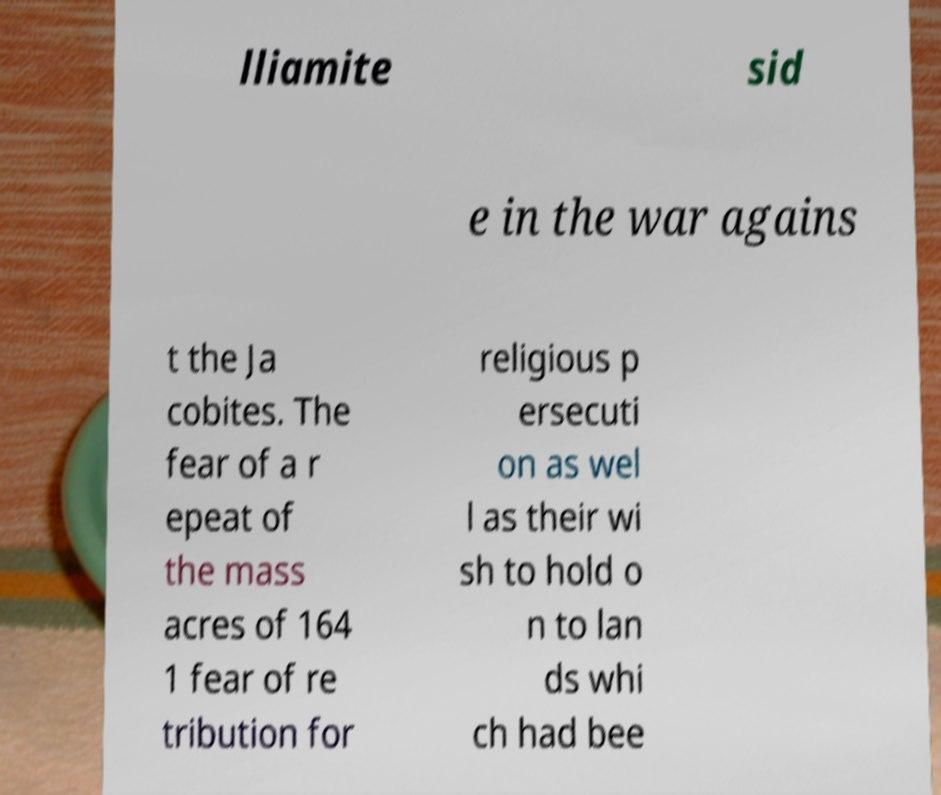For documentation purposes, I need the text within this image transcribed. Could you provide that? lliamite sid e in the war agains t the Ja cobites. The fear of a r epeat of the mass acres of 164 1 fear of re tribution for religious p ersecuti on as wel l as their wi sh to hold o n to lan ds whi ch had bee 